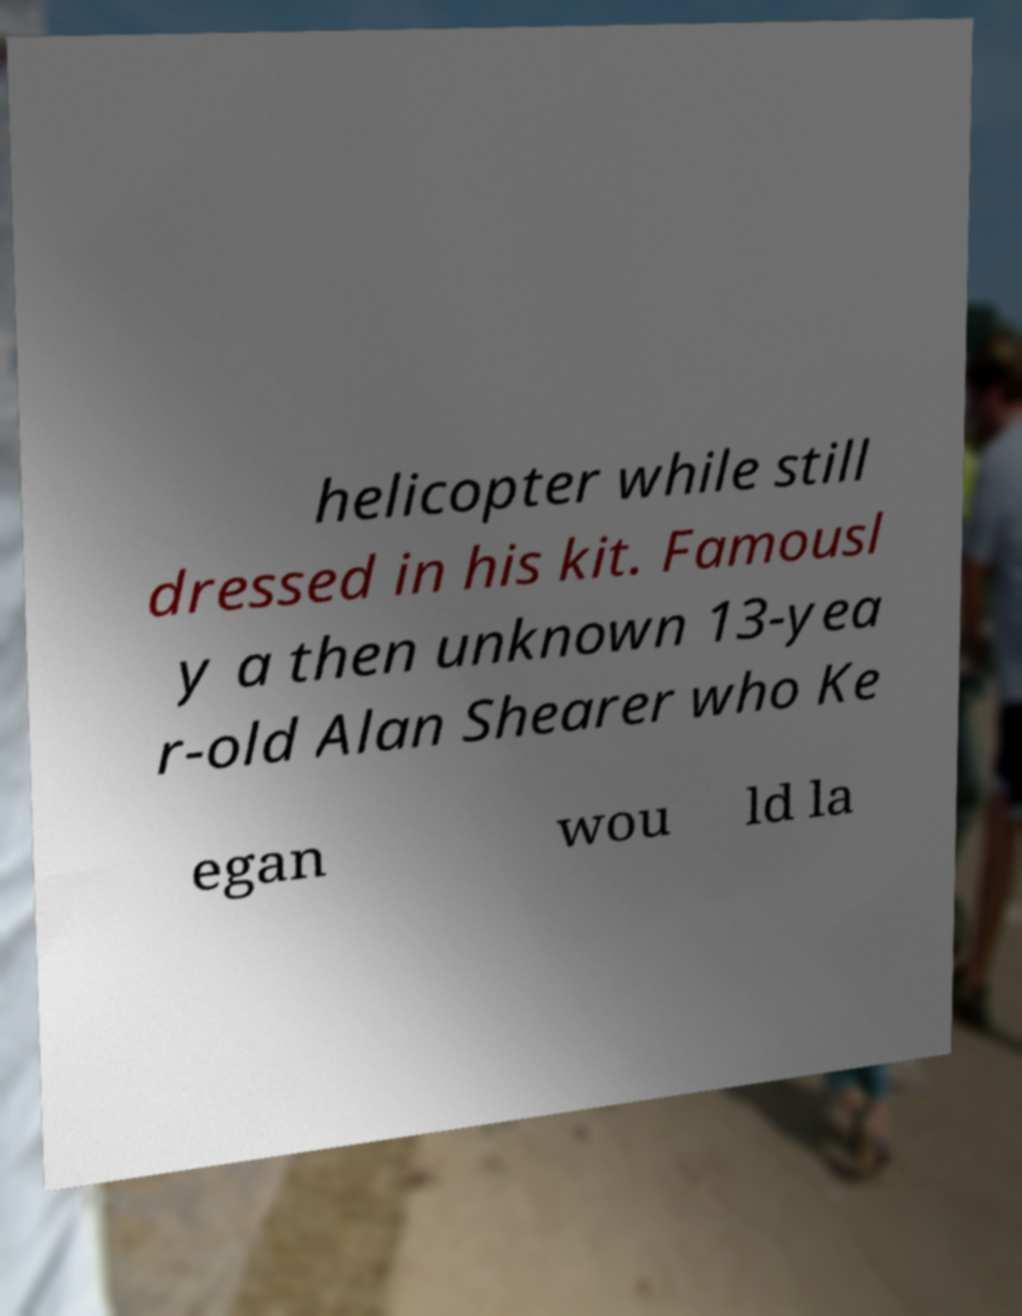Can you accurately transcribe the text from the provided image for me? helicopter while still dressed in his kit. Famousl y a then unknown 13-yea r-old Alan Shearer who Ke egan wou ld la 